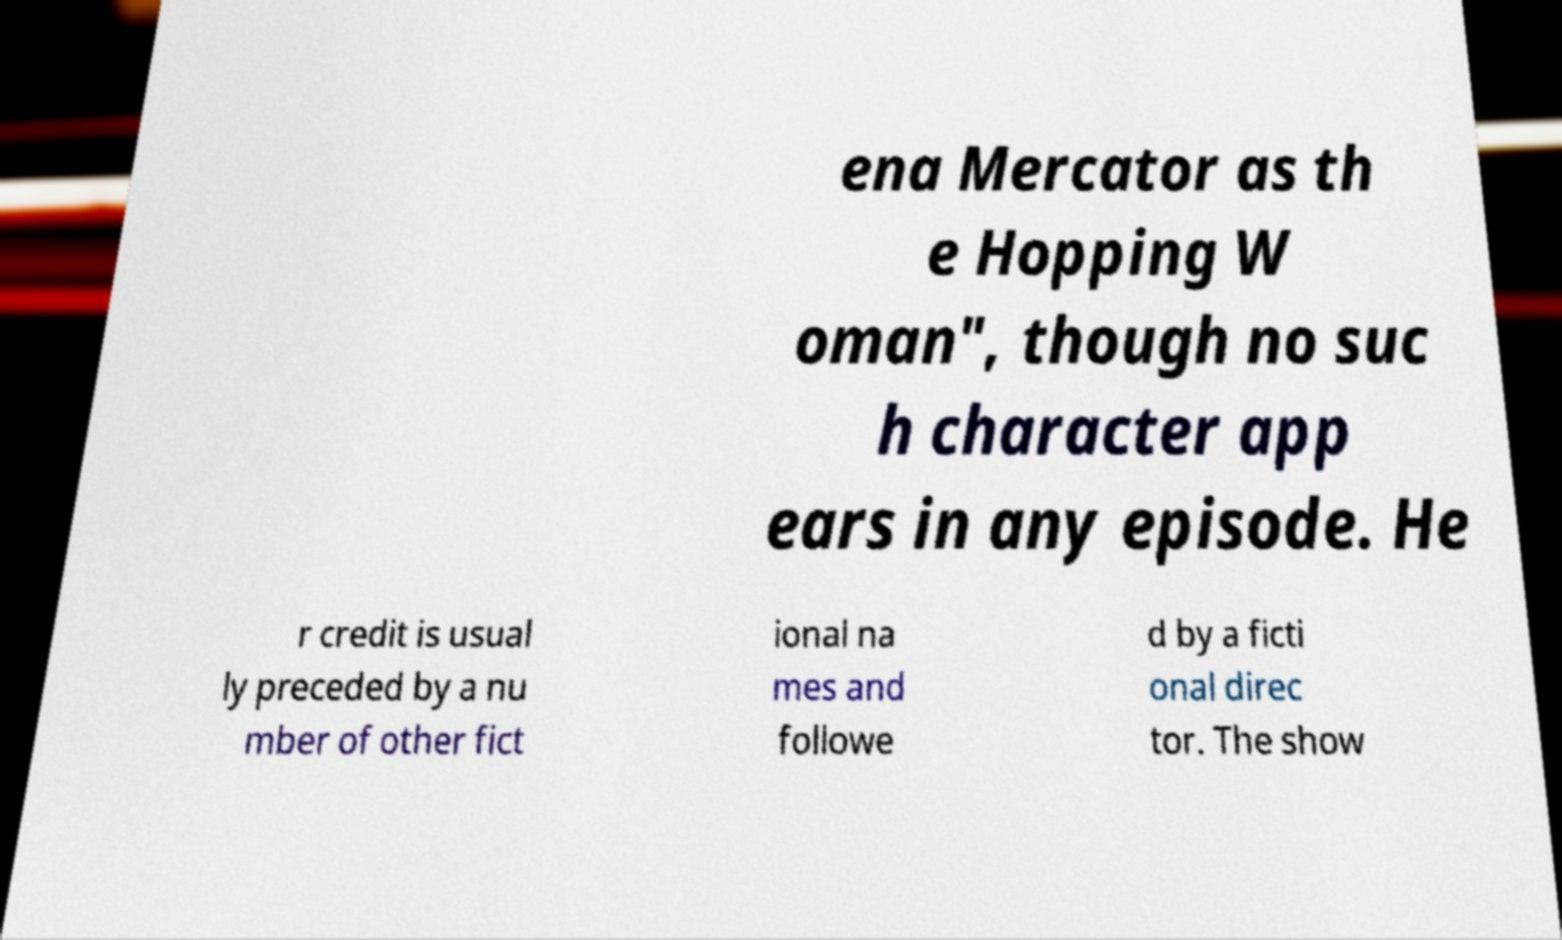Could you extract and type out the text from this image? ena Mercator as th e Hopping W oman", though no suc h character app ears in any episode. He r credit is usual ly preceded by a nu mber of other fict ional na mes and followe d by a ficti onal direc tor. The show 